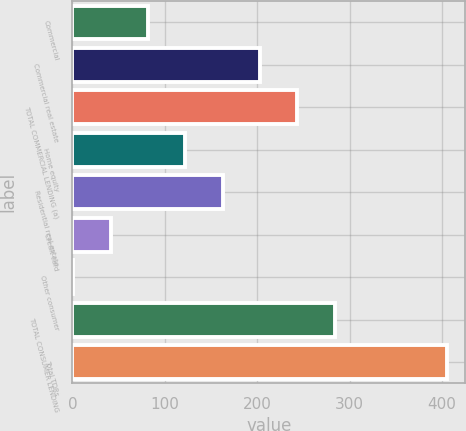<chart> <loc_0><loc_0><loc_500><loc_500><bar_chart><fcel>Commercial<fcel>Commercial real estate<fcel>TOTAL COMMERCIAL LENDING (a)<fcel>Home equity<fcel>Residential real estate<fcel>Credit card<fcel>Other consumer<fcel>TOTAL CONSUMER LENDING<fcel>Total TDRs<nl><fcel>81.8<fcel>203<fcel>243.4<fcel>122.2<fcel>162.6<fcel>41.4<fcel>1<fcel>283.8<fcel>405<nl></chart> 